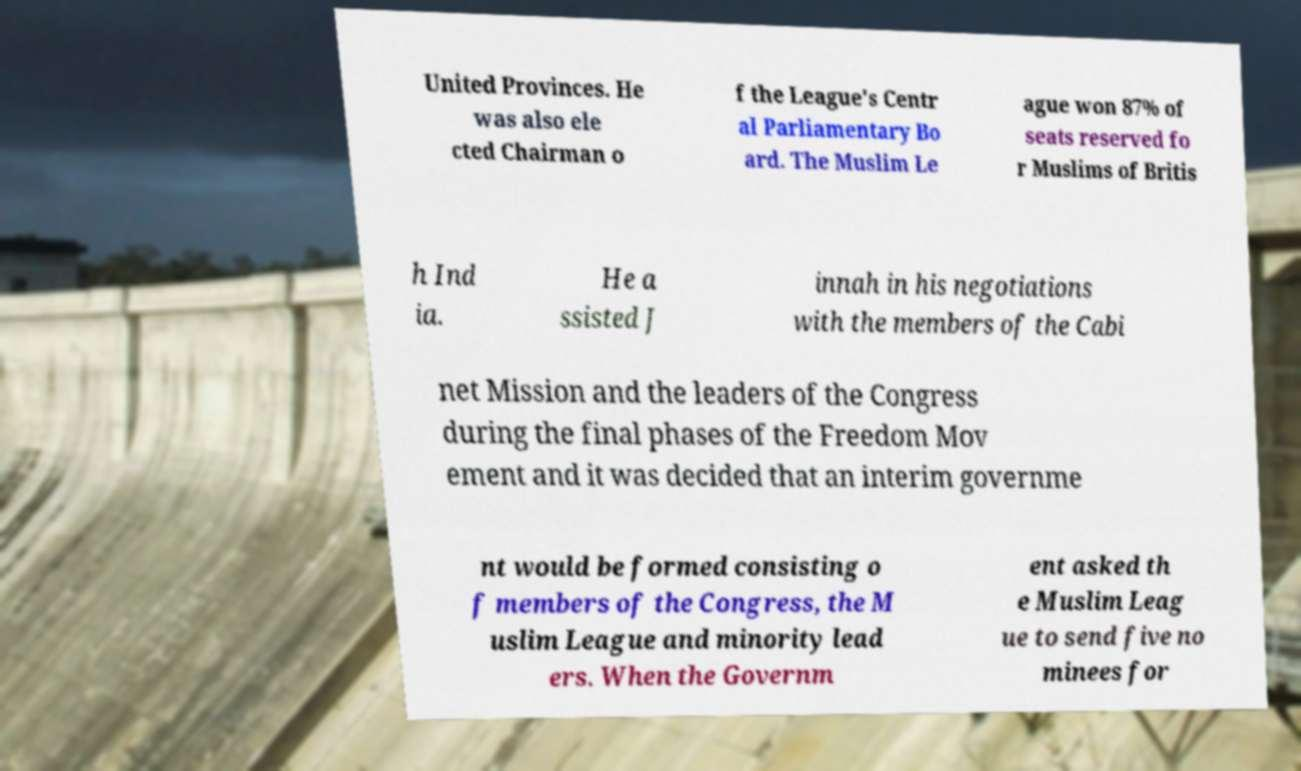Could you assist in decoding the text presented in this image and type it out clearly? United Provinces. He was also ele cted Chairman o f the League's Centr al Parliamentary Bo ard. The Muslim Le ague won 87% of seats reserved fo r Muslims of Britis h Ind ia. He a ssisted J innah in his negotiations with the members of the Cabi net Mission and the leaders of the Congress during the final phases of the Freedom Mov ement and it was decided that an interim governme nt would be formed consisting o f members of the Congress, the M uslim League and minority lead ers. When the Governm ent asked th e Muslim Leag ue to send five no minees for 